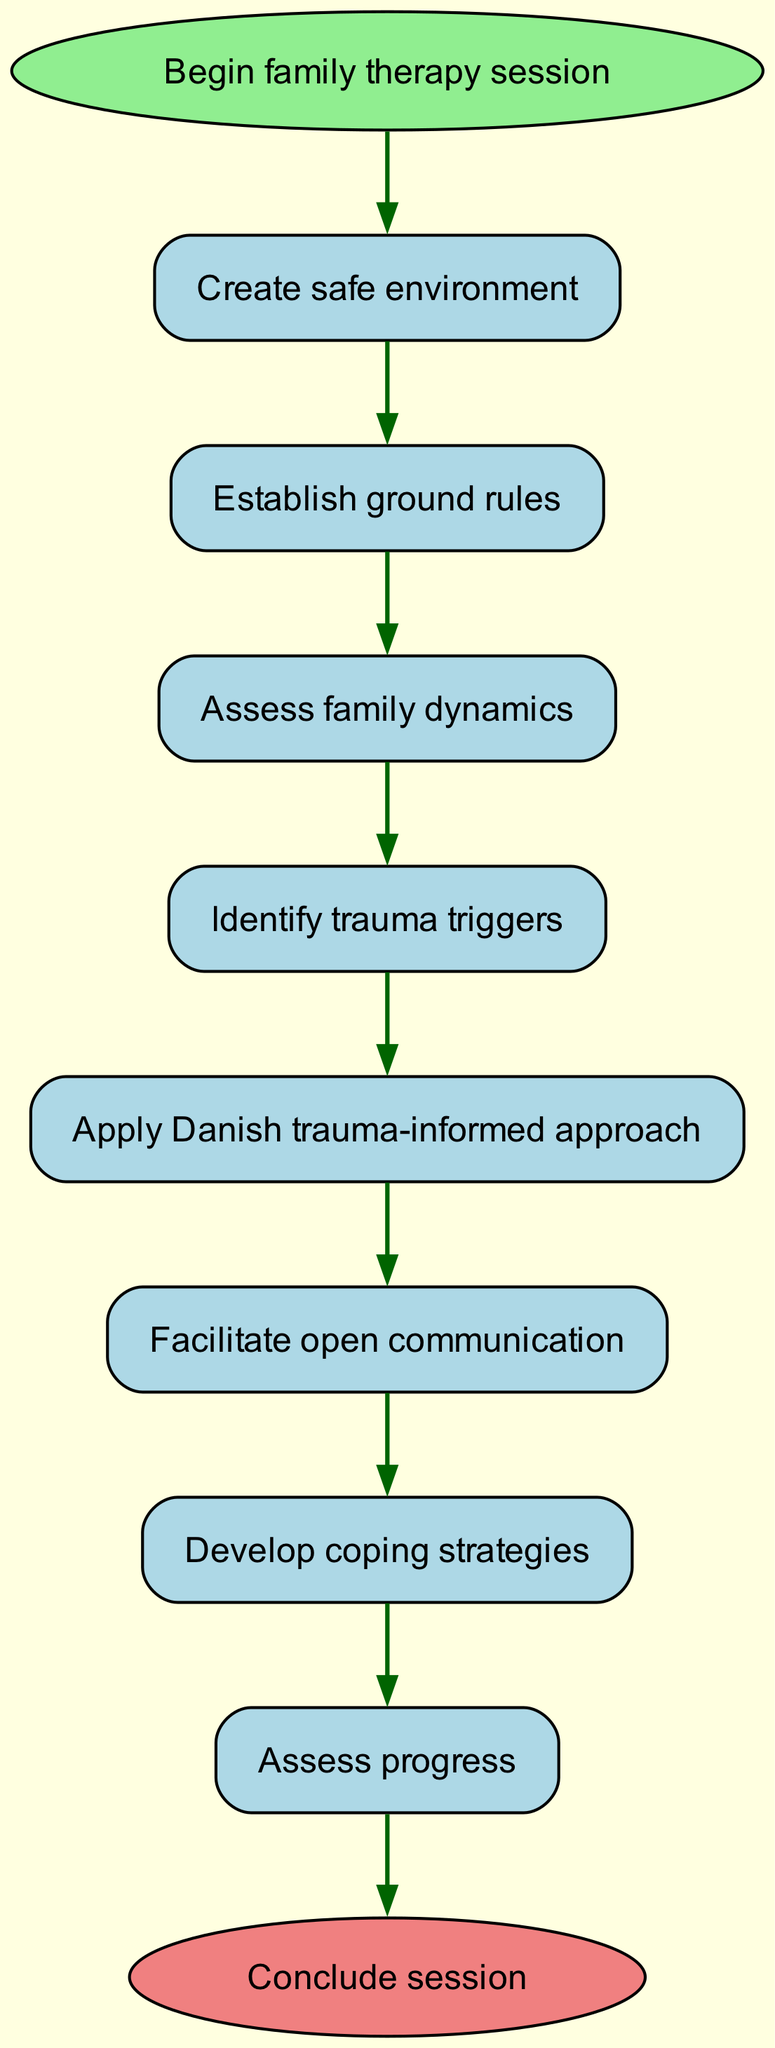What is the first step in the family therapy session? The diagram indicates that the first step is labeled "Create safe environment." This information is found directly from the starting point of the flow chart, which leads into the sequence of steps.
Answer: Create safe environment How many steps are there in total? By counting each step listed in the diagram, including the start and end nodes, we find that there are eight steps in total. This includes the initial step and the final conclusion.
Answer: 8 What step comes after "Facilitate open communication"? According to the flow of the diagram, the step that follows "Facilitate open communication" is "Develop coping strategies." This is determined by identifying the directed edge that originates from the "Facilitate open communication" node.
Answer: Develop coping strategies What is the last step in the process? The end node of the flow chart specifies "Conclude session" as the final step in the therapy session process. This is directly derived from following the sequence of steps to their conclusion.
Answer: Conclude session In how many instances is "Assess" used in the steps? Looking through the steps in the diagram, "Assess" appears twice in the phrases "Assess family dynamics" and "Assess progress." This count is obtained by identifying all occurrences of the word in the steps listed.
Answer: 2 What is the relationship between "Identify trauma triggers" and "Apply Danish trauma-informed approach"? The diagram shows a directed edge from "Identify trauma triggers" to "Apply Danish trauma-informed approach." This indicates that the first step leads directly into the second within the flow of the therapy session.
Answer: Directly connected What does the therapy session prioritize immediately after creating a safe environment? Following the step "Create safe environment," the next focus is "Establish ground rules." This is specified by the flow leading from the initial step to the subsequent one.
Answer: Establish ground rules How is communication handled in the session? The session involves "Facilitate open communication" as a key step. This step emphasizes the importance of allowing dialogue and expression among family members, which is explicitly depicted in the diagram.
Answer: Facilitate open communication What is the penultimate step before concluding the session? The step that occurs directly before "Conclude session" is "Assess progress." This is determined by tracing the flow from the second-to-last step to the ending point of the diagram.
Answer: Assess progress 